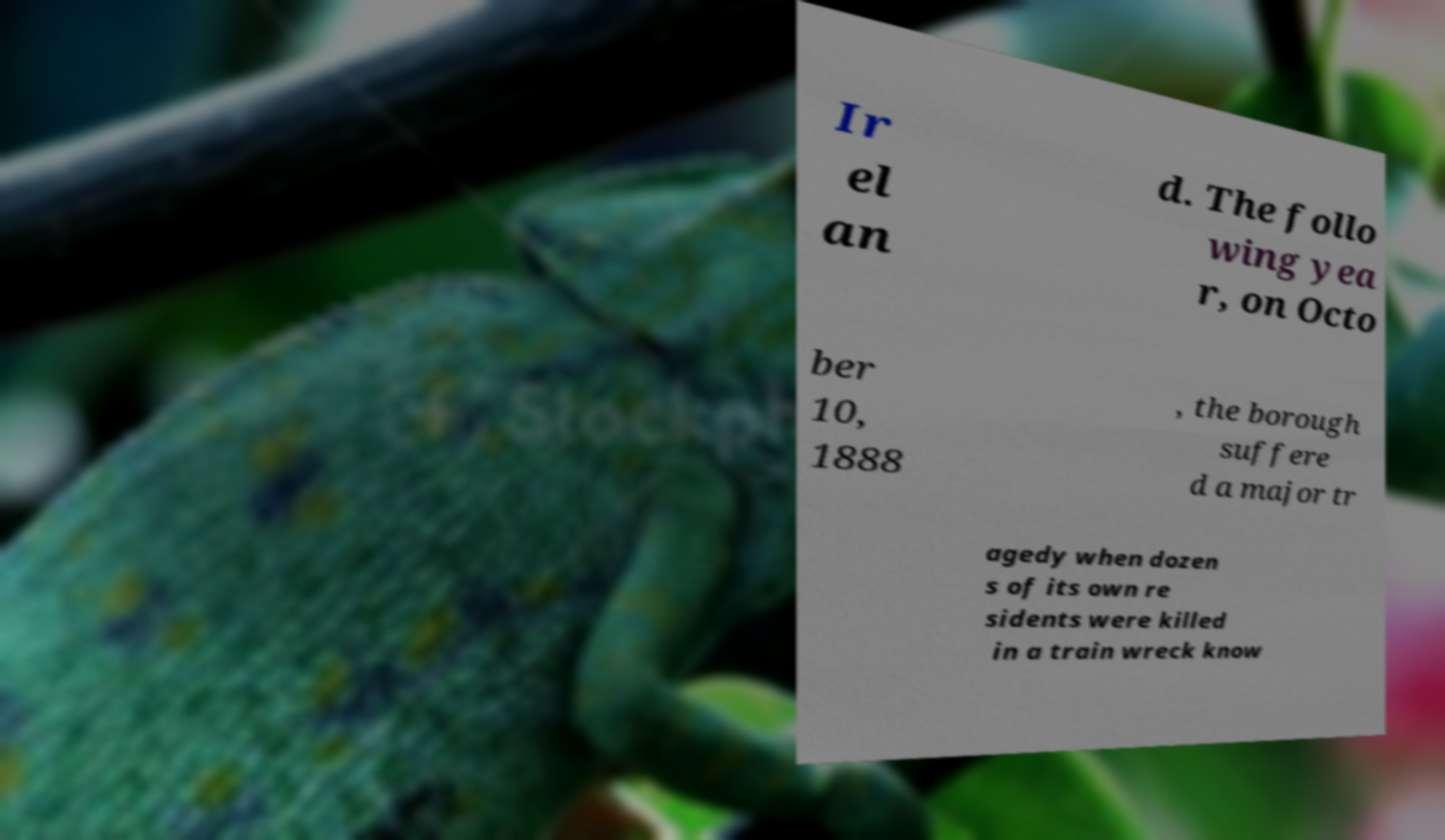Please read and relay the text visible in this image. What does it say? Ir el an d. The follo wing yea r, on Octo ber 10, 1888 , the borough suffere d a major tr agedy when dozen s of its own re sidents were killed in a train wreck know 